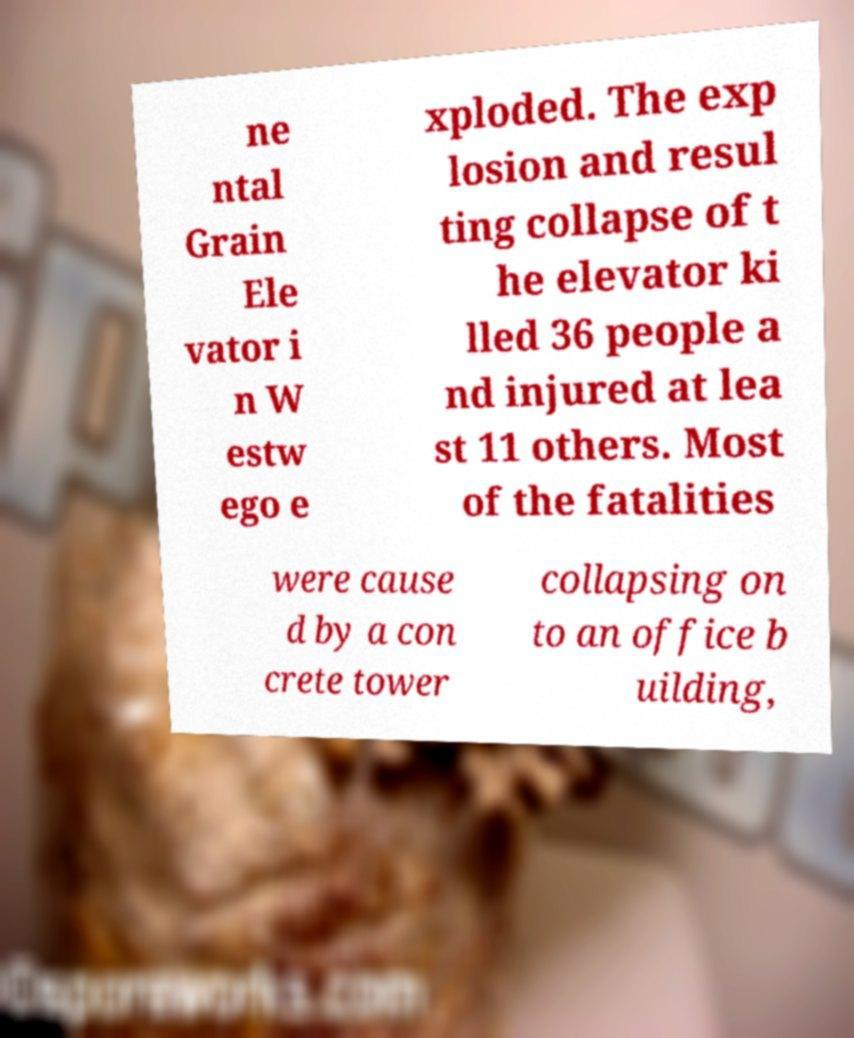Please read and relay the text visible in this image. What does it say? ne ntal Grain Ele vator i n W estw ego e xploded. The exp losion and resul ting collapse of t he elevator ki lled 36 people a nd injured at lea st 11 others. Most of the fatalities were cause d by a con crete tower collapsing on to an office b uilding, 